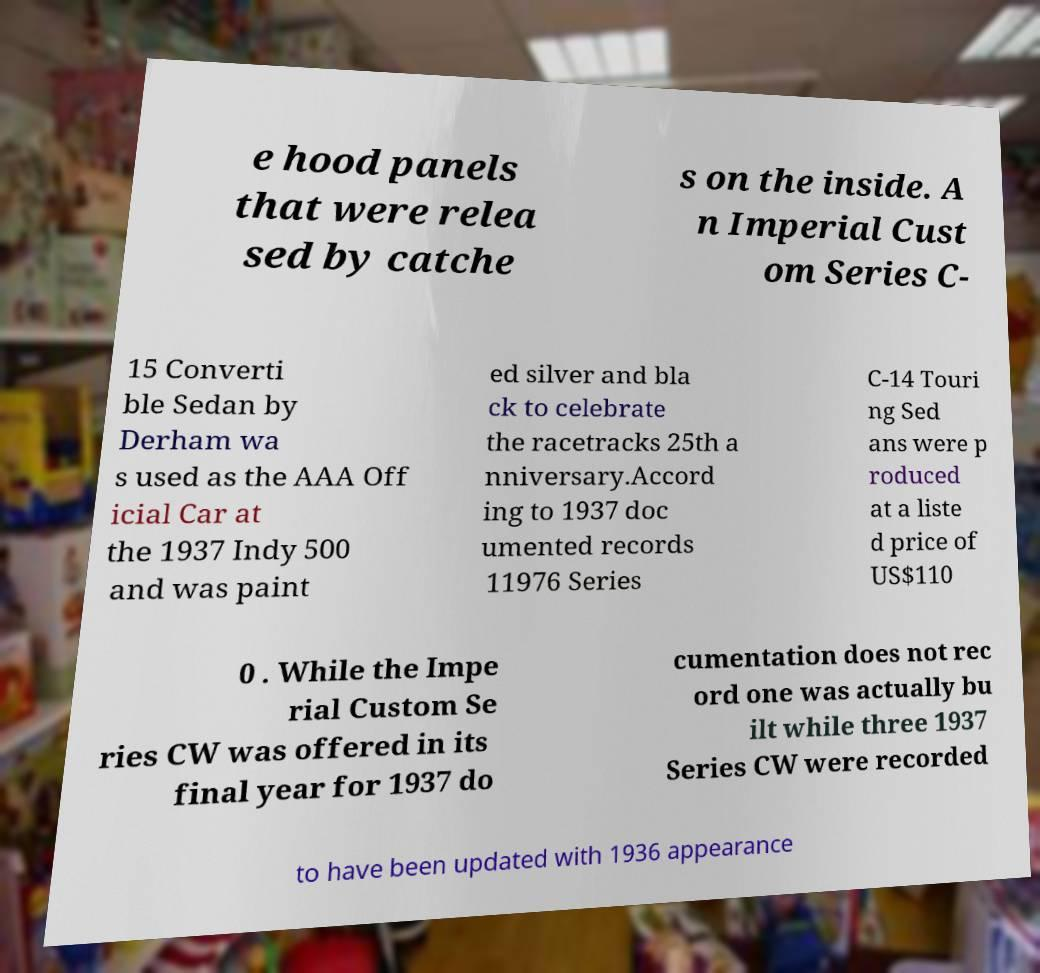Can you accurately transcribe the text from the provided image for me? e hood panels that were relea sed by catche s on the inside. A n Imperial Cust om Series C- 15 Converti ble Sedan by Derham wa s used as the AAA Off icial Car at the 1937 Indy 500 and was paint ed silver and bla ck to celebrate the racetracks 25th a nniversary.Accord ing to 1937 doc umented records 11976 Series C-14 Touri ng Sed ans were p roduced at a liste d price of US$110 0 . While the Impe rial Custom Se ries CW was offered in its final year for 1937 do cumentation does not rec ord one was actually bu ilt while three 1937 Series CW were recorded to have been updated with 1936 appearance 